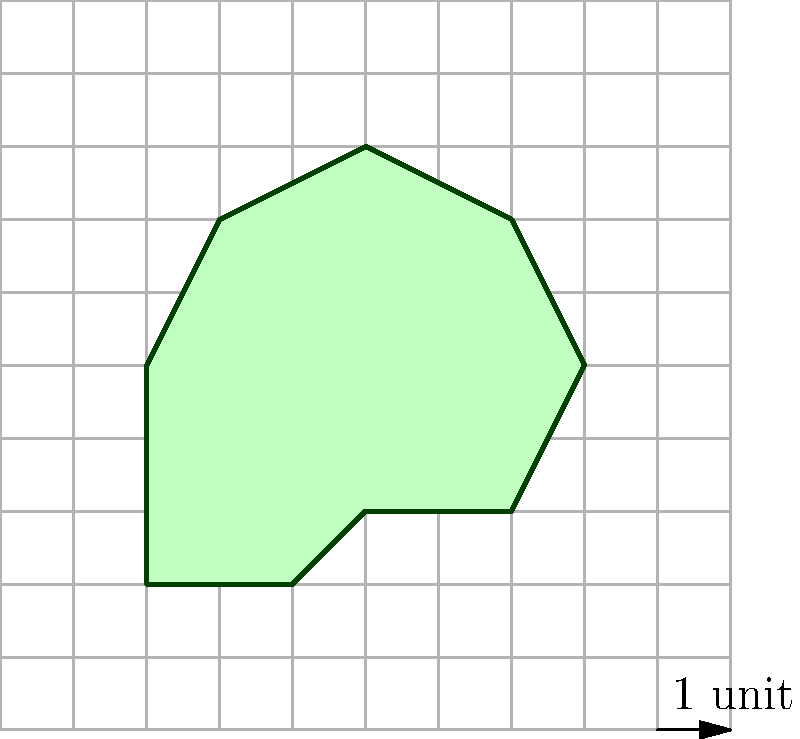As a nature enthusiast working on a wildlife conservation project, you need to calculate the perimeter of an irregularly shaped pond habitat. Using the grid system provided, where each square represents 1 unit, determine the approximate perimeter of the pond. Round your answer to the nearest whole number. To calculate the approximate perimeter of the irregularly shaped pond, we'll follow these steps:

1. Count the number of grid lines crossed by the pond's boundary:
   - Horizontal lines crossed: 8
   - Vertical lines crossed: 10

2. Calculate the total number of intersections:
   $8 + 10 = 18$ intersections

3. Apply the formula for estimating the perimeter of an irregular shape using a grid system:
   $\text{Perimeter} \approx \text{Number of intersections} \times \text{Grid size} \times \frac{\pi}{4}$

4. Substitute the values:
   $\text{Perimeter} \approx 18 \times 1 \times \frac{\pi}{4}$

5. Calculate:
   $\text{Perimeter} \approx 18 \times 0.7854 \approx 14.1372$

6. Round to the nearest whole number:
   $\text{Perimeter} \approx 14$ units

This method, known as the grid intersection method, provides a reasonably accurate approximation of the perimeter for irregular shapes, which is particularly useful in ecological studies and habitat assessments.
Answer: 14 units 